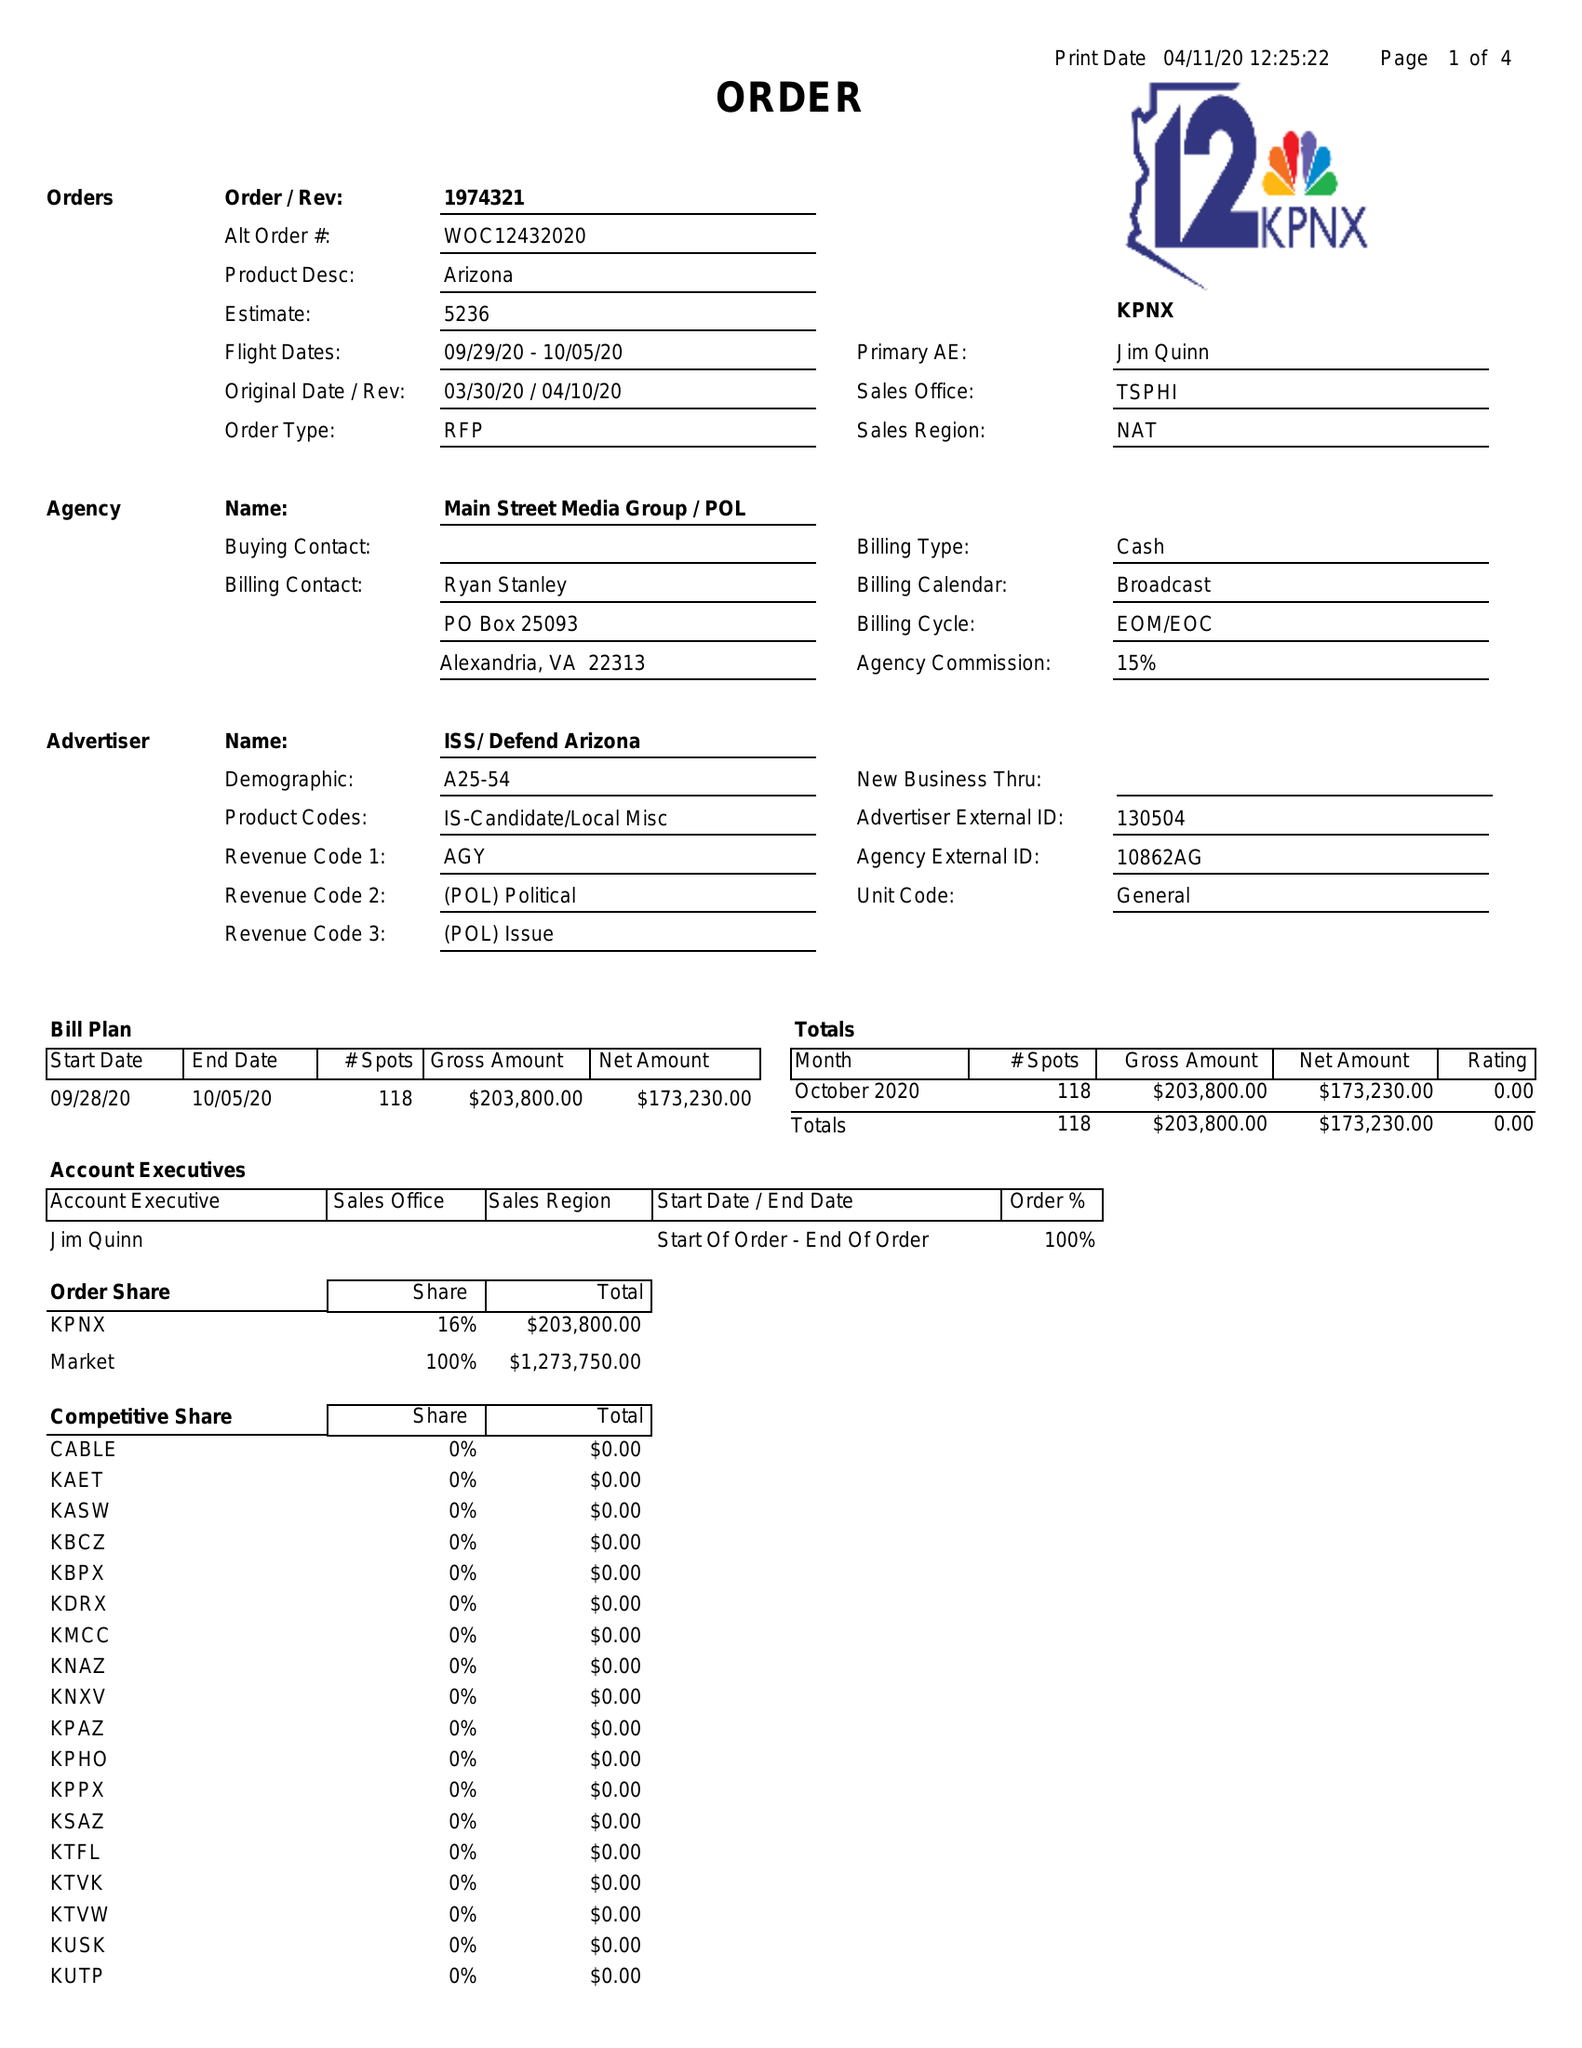What is the value for the contract_num?
Answer the question using a single word or phrase. 1974321 